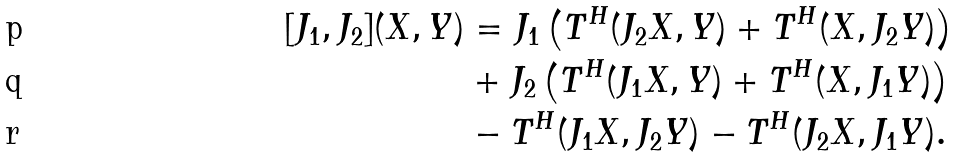<formula> <loc_0><loc_0><loc_500><loc_500>[ J _ { 1 } , J _ { 2 } ] ( X , Y ) & = J _ { 1 } \left ( T ^ { H } ( J _ { 2 } X , Y ) + T ^ { H } ( X , J _ { 2 } Y ) \right ) \\ & + J _ { 2 } \left ( T ^ { H } ( J _ { 1 } X , Y ) + T ^ { H } ( X , J _ { 1 } Y ) \right ) \\ & - T ^ { H } ( J _ { 1 } X , J _ { 2 } Y ) - T ^ { H } ( J _ { 2 } X , J _ { 1 } Y ) .</formula> 